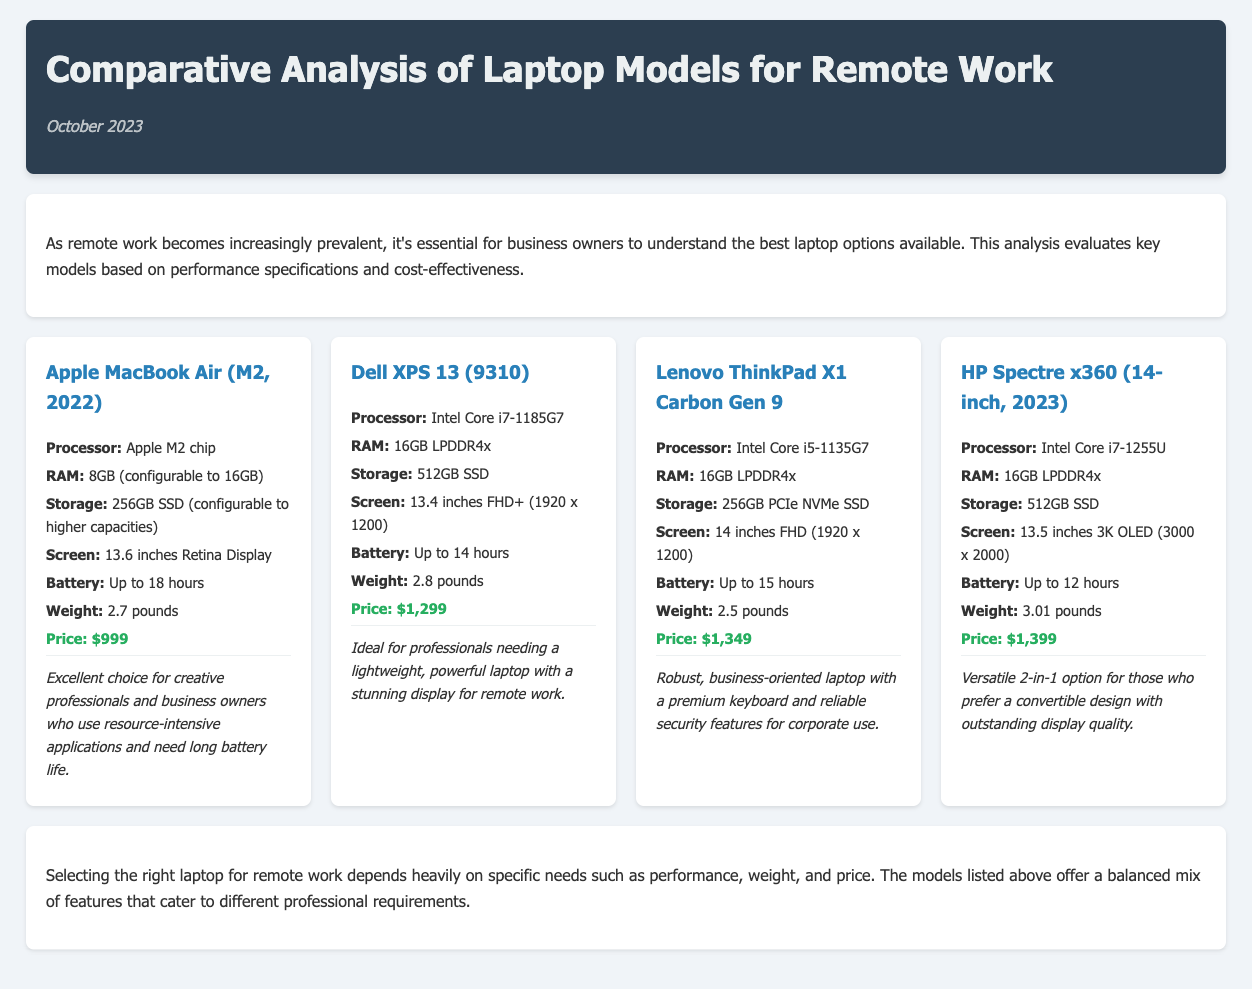what is the processor of the Dell XPS 13? The processor information for the Dell XPS 13 is found in the laptop card section, which states it has an Intel Core i7-1185G7.
Answer: Intel Core i7-1185G7 how much RAM does the Lenovo ThinkPad X1 Carbon Gen 9 have? The RAM specification for the Lenovo ThinkPad X1 Carbon Gen 9 indicates it has 16GB LPDDR4x.
Answer: 16GB LPDDR4x what is the price of the HP Spectre x360? The price listed for the HP Spectre x360 in the document is explicitly mentioned as $1,399.
Answer: $1,399 which laptop has the longest battery life? To identify the laptop with the longest battery life, compare the battery specifications of each model; the Apple MacBook Air has up to 18 hours.
Answer: Apple MacBook Air which model is described as an excellent choice for creative professionals? The use case description for the Apple MacBook Air specifies it as an excellent choice for creative professionals and business owners.
Answer: Apple MacBook Air what is the weight of the Lenovo ThinkPad X1 Carbon Gen 9? The weight information for the Lenovo ThinkPad X1 Carbon Gen 9 is found in the specifications section as 2.5 pounds.
Answer: 2.5 pounds which laptop has a screen size of 14 inches? The size of the screen for the Lenovo ThinkPad X1 Carbon Gen 9 is specifically stated as 14 inches FHD.
Answer: 14 inches what type of display does the HP Spectre x360 feature? The display information for the HP Spectre x360 mentions that it has a 3K OLED screen.
Answer: 3K OLED how many laptop models are compared in the analysis? The analysis mentions four different laptop models in the comparative section, reflecting specific features for each.
Answer: Four 